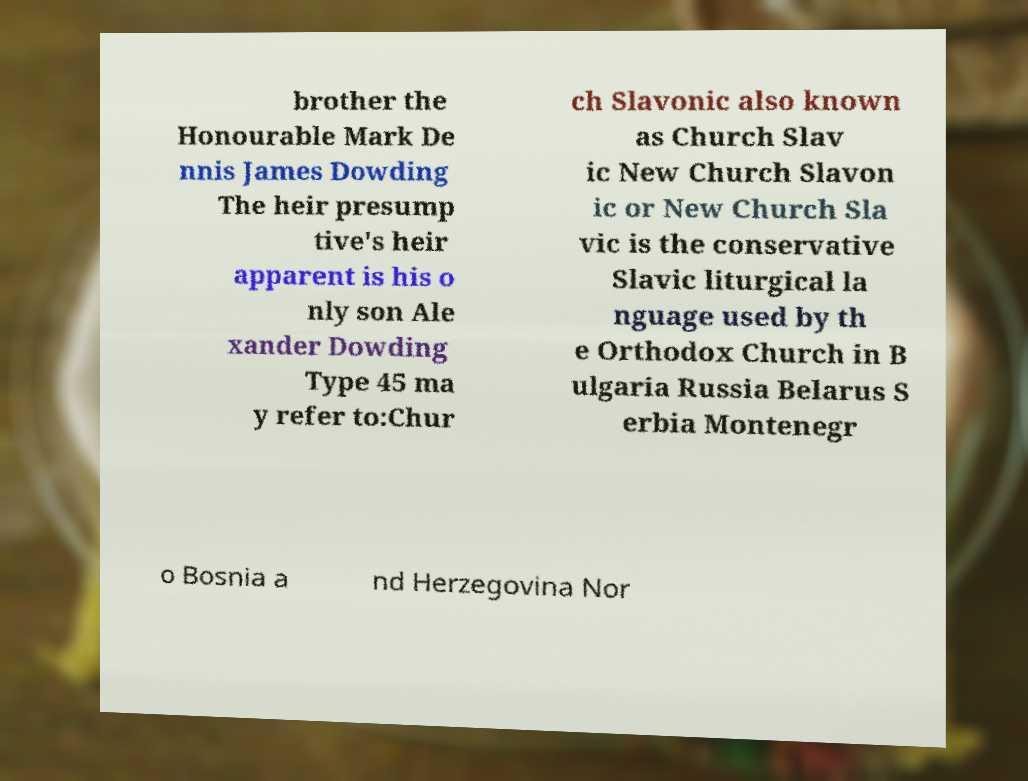What messages or text are displayed in this image? I need them in a readable, typed format. brother the Honourable Mark De nnis James Dowding The heir presump tive's heir apparent is his o nly son Ale xander Dowding Type 45 ma y refer to:Chur ch Slavonic also known as Church Slav ic New Church Slavon ic or New Church Sla vic is the conservative Slavic liturgical la nguage used by th e Orthodox Church in B ulgaria Russia Belarus S erbia Montenegr o Bosnia a nd Herzegovina Nor 